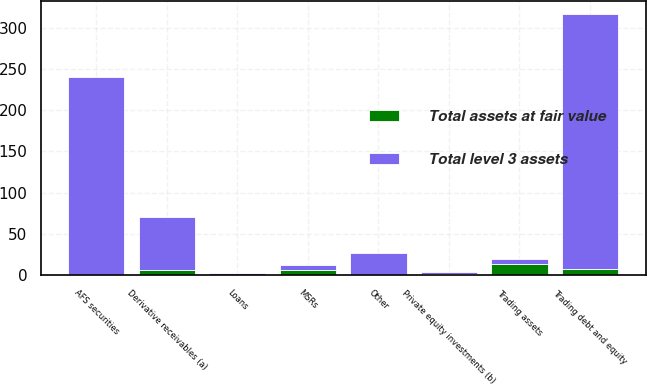Convert chart. <chart><loc_0><loc_0><loc_500><loc_500><stacked_bar_chart><ecel><fcel>Trading debt and equity<fcel>Derivative receivables (a)<fcel>Trading assets<fcel>AFS securities<fcel>Loans<fcel>MSRs<fcel>Private equity investments (b)<fcel>Other<nl><fcel>Total level 3 assets<fcel>308<fcel>64.1<fcel>6.1<fcel>238.9<fcel>2.2<fcel>6.1<fcel>1.7<fcel>26.4<nl><fcel>Total assets at fair value<fcel>7.9<fcel>5.8<fcel>13.7<fcel>0.7<fcel>0.6<fcel>6.1<fcel>1.6<fcel>0.5<nl></chart> 